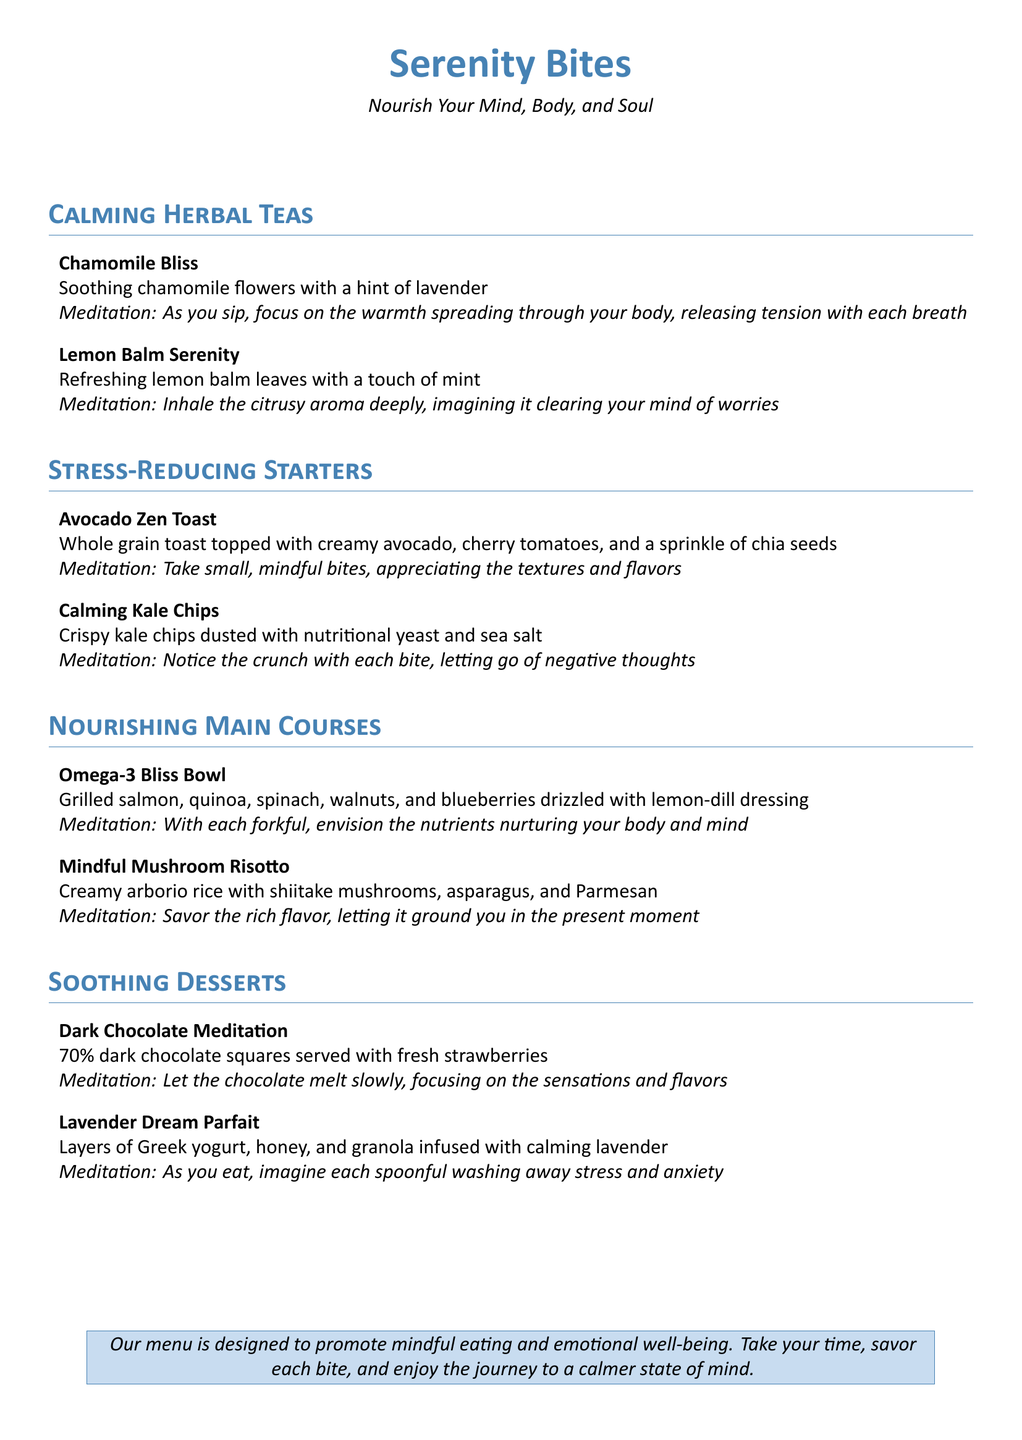What is the name of the calming herbal tea made with chamomile? The menu lists a calming herbal tea called "Chamomile Bliss."
Answer: Chamomile Bliss Which dish contains quinoa and walnuts? The "Omega-3 Bliss Bowl" is the dish that contains quinoa and walnuts.
Answer: Omega-3 Bliss Bowl What is the main ingredient in the Lavender Dream Parfait? The main ingredient listed in the Lavender Dream Parfait is Greek yogurt.
Answer: Greek yogurt How many stress-reducing starters are offered on the menu? There are two starters listed under stress-reducing starters: Avocado Zen Toast and Calming Kale Chips.
Answer: 2 What type of chocolate is served in the Dark Chocolate Meditation? The Dark Chocolate Meditation features 70% dark chocolate.
Answer: 70% What meditation prompt is associated with the Omega-3 Bliss Bowl? The meditation prompt associated with the Omega-3 Bliss Bowl involves envisioning nutrients nurturing the body and mind.
Answer: Envision the nutrients nurturing your body and mind What is the color used for the heading of the sections? The heading color used for the sections is described as "maincolor," which corresponds to a specific RGB value (70,130,180).
Answer: maincolor What are the flavors in the Chamomile Bliss tea? The flavors in Chamomile Bliss tea include soothing chamomile flowers and a hint of lavender.
Answer: Soothing chamomile flowers with a hint of lavender 